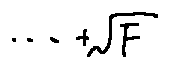<formula> <loc_0><loc_0><loc_500><loc_500>\cdots + \sqrt { F }</formula> 